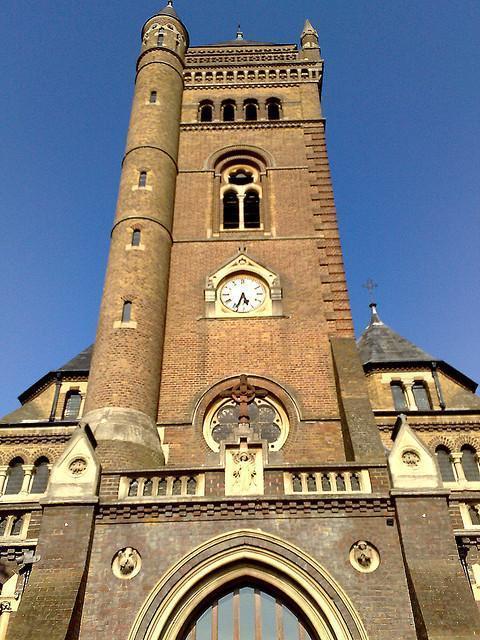How many cylindrical towers?
Give a very brief answer. 1. 